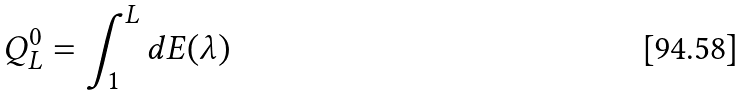Convert formula to latex. <formula><loc_0><loc_0><loc_500><loc_500>Q ^ { 0 } _ { L } = \int _ { 1 } ^ { L } d E ( \lambda )</formula> 